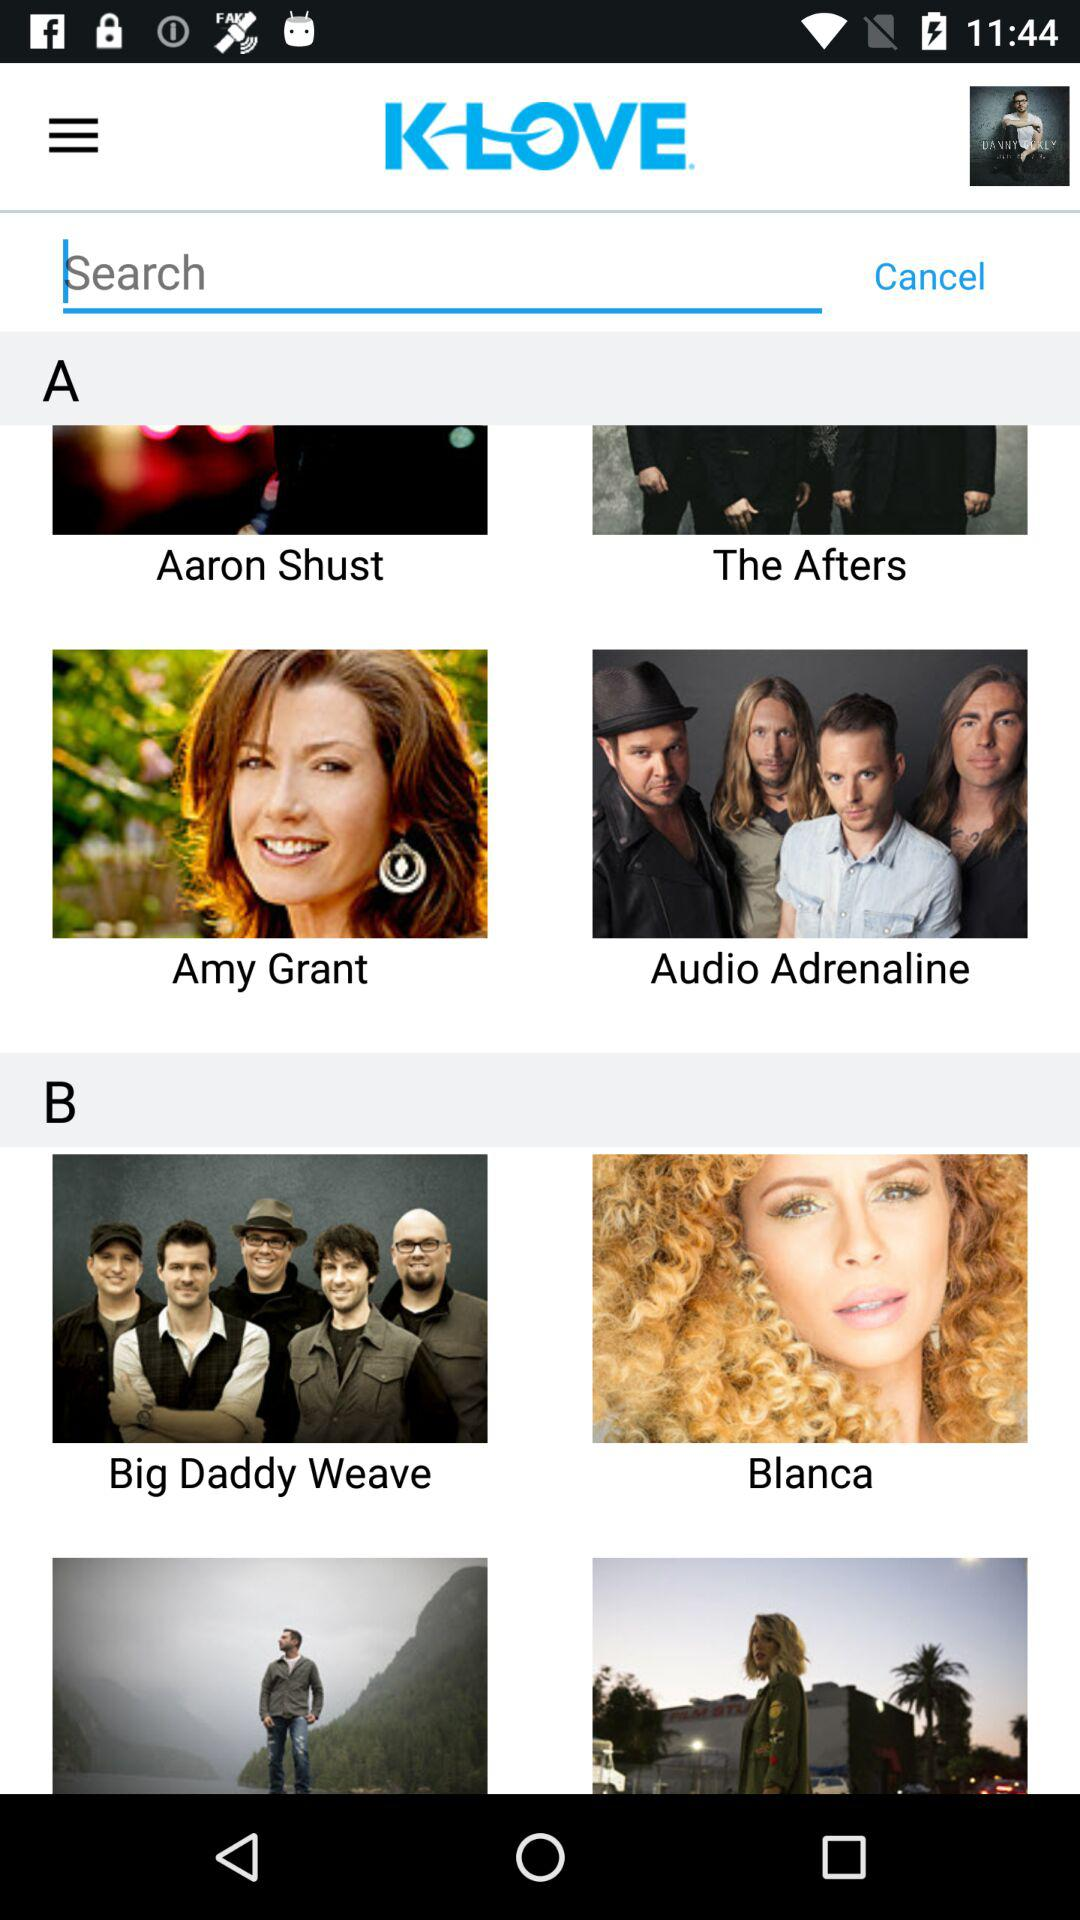What is the name of the application? The name of the application is KLOVE. 